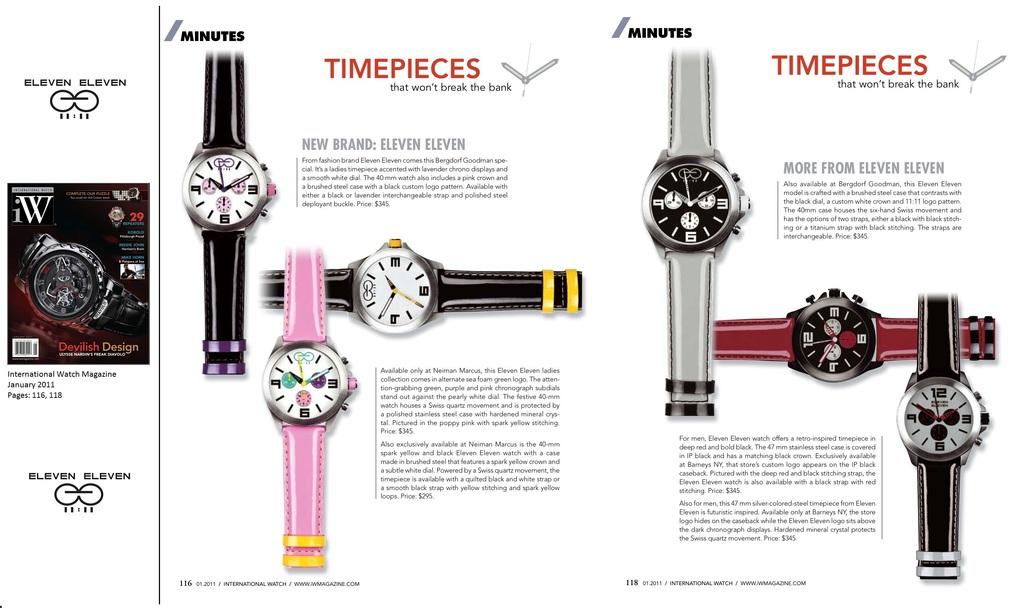What is the brand of watch?
Ensure brevity in your answer.  Eleven eleven. 